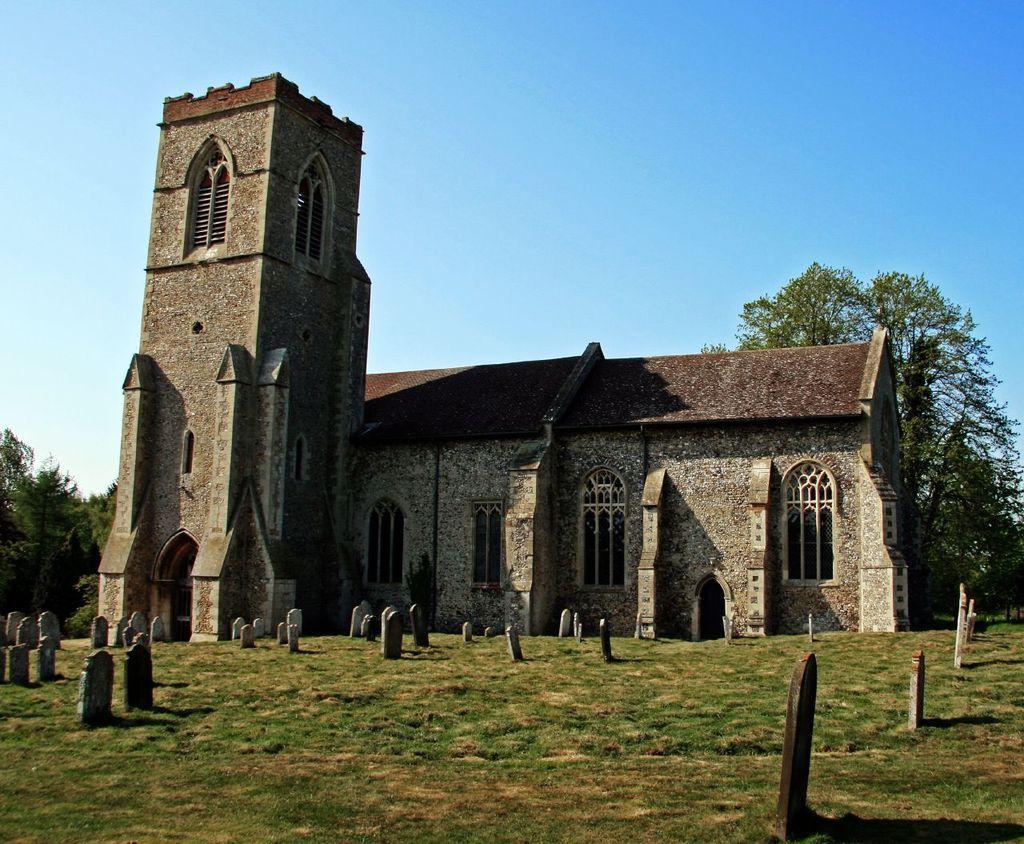How would you summarize this image in a sentence or two? In this picture there is a building and there are few headstones placed on a greenery ground in front of it and there are trees in the background. 